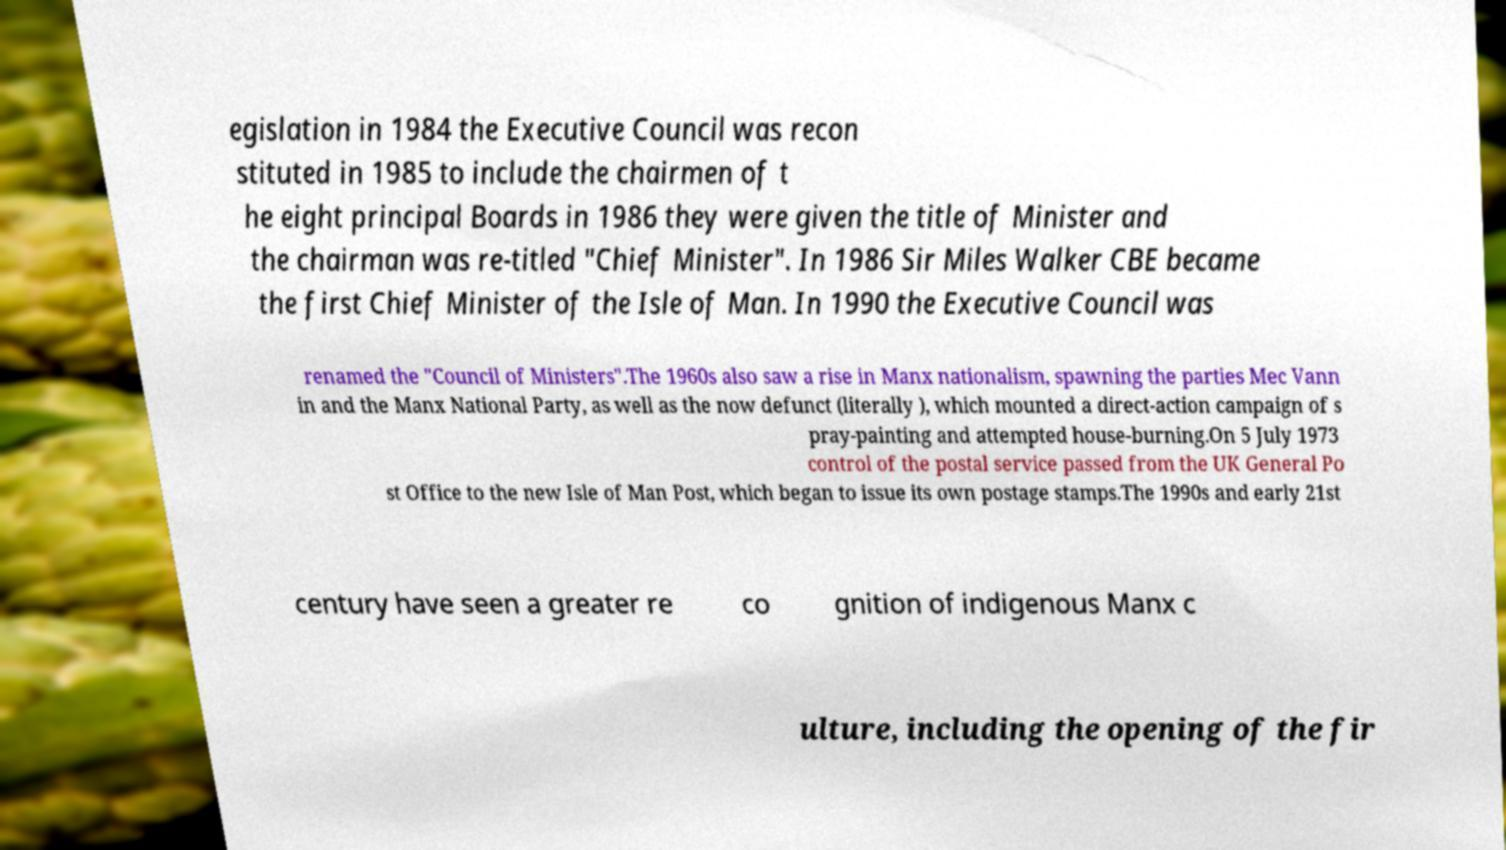There's text embedded in this image that I need extracted. Can you transcribe it verbatim? egislation in 1984 the Executive Council was recon stituted in 1985 to include the chairmen of t he eight principal Boards in 1986 they were given the title of Minister and the chairman was re-titled "Chief Minister". In 1986 Sir Miles Walker CBE became the first Chief Minister of the Isle of Man. In 1990 the Executive Council was renamed the "Council of Ministers".The 1960s also saw a rise in Manx nationalism, spawning the parties Mec Vann in and the Manx National Party, as well as the now defunct (literally ), which mounted a direct-action campaign of s pray-painting and attempted house-burning.On 5 July 1973 control of the postal service passed from the UK General Po st Office to the new Isle of Man Post, which began to issue its own postage stamps.The 1990s and early 21st century have seen a greater re co gnition of indigenous Manx c ulture, including the opening of the fir 